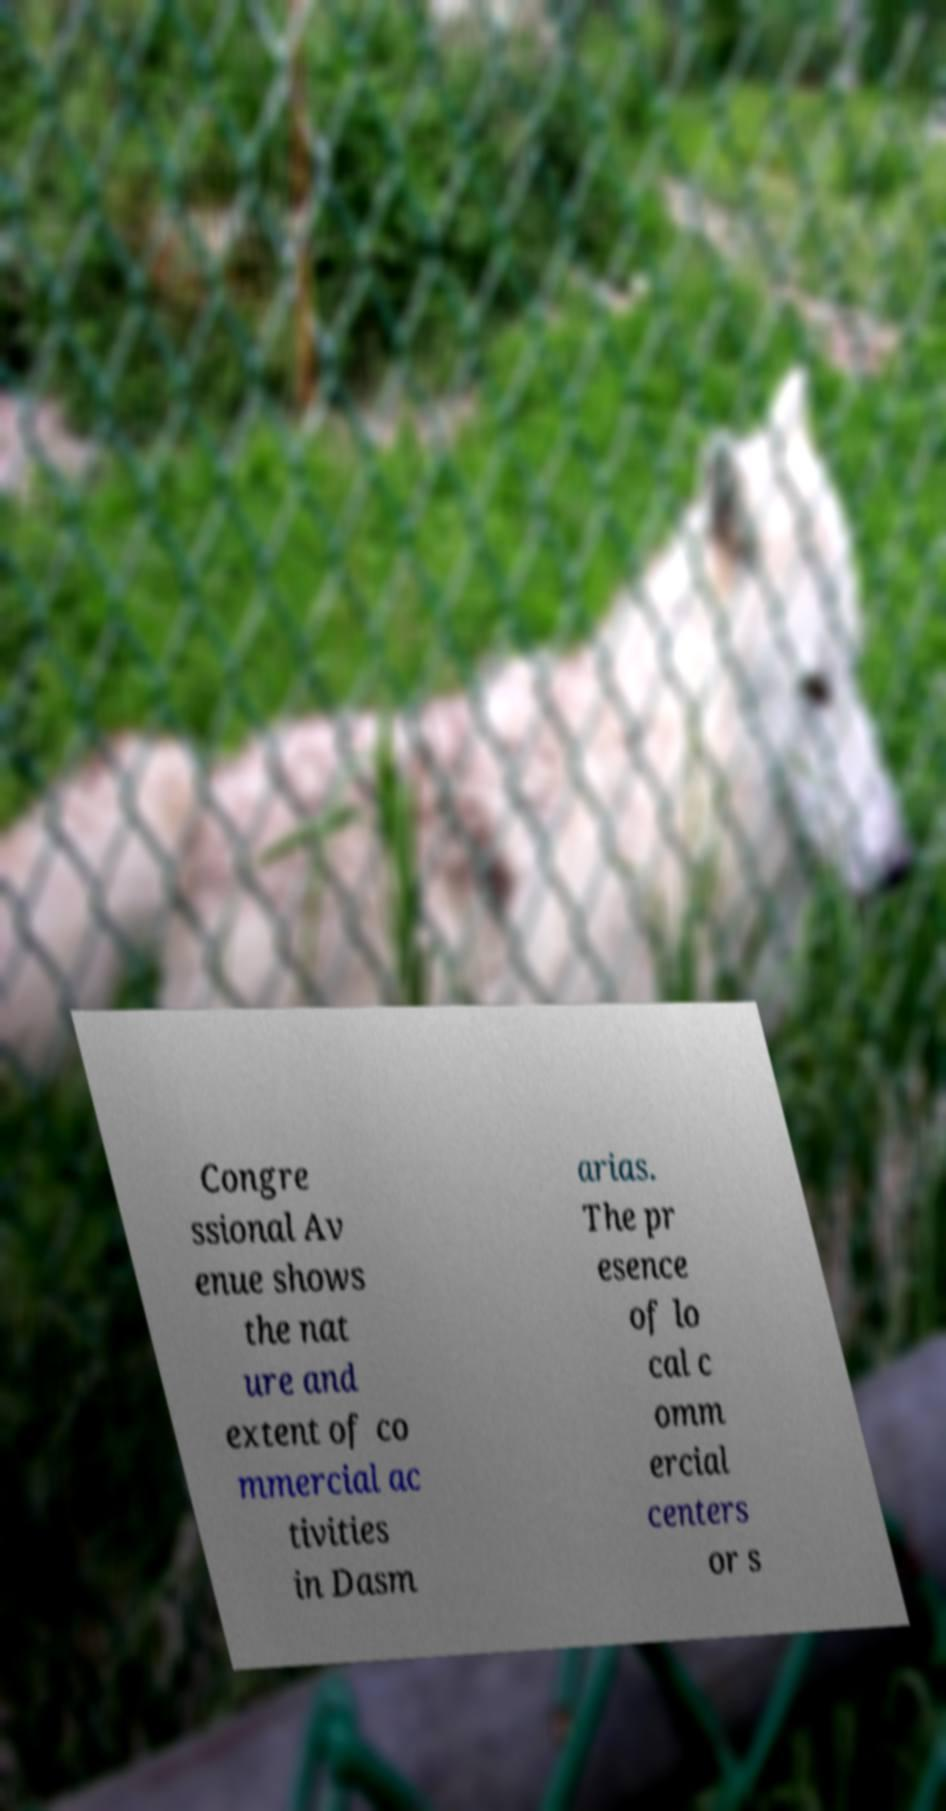Could you assist in decoding the text presented in this image and type it out clearly? Congre ssional Av enue shows the nat ure and extent of co mmercial ac tivities in Dasm arias. The pr esence of lo cal c omm ercial centers or s 